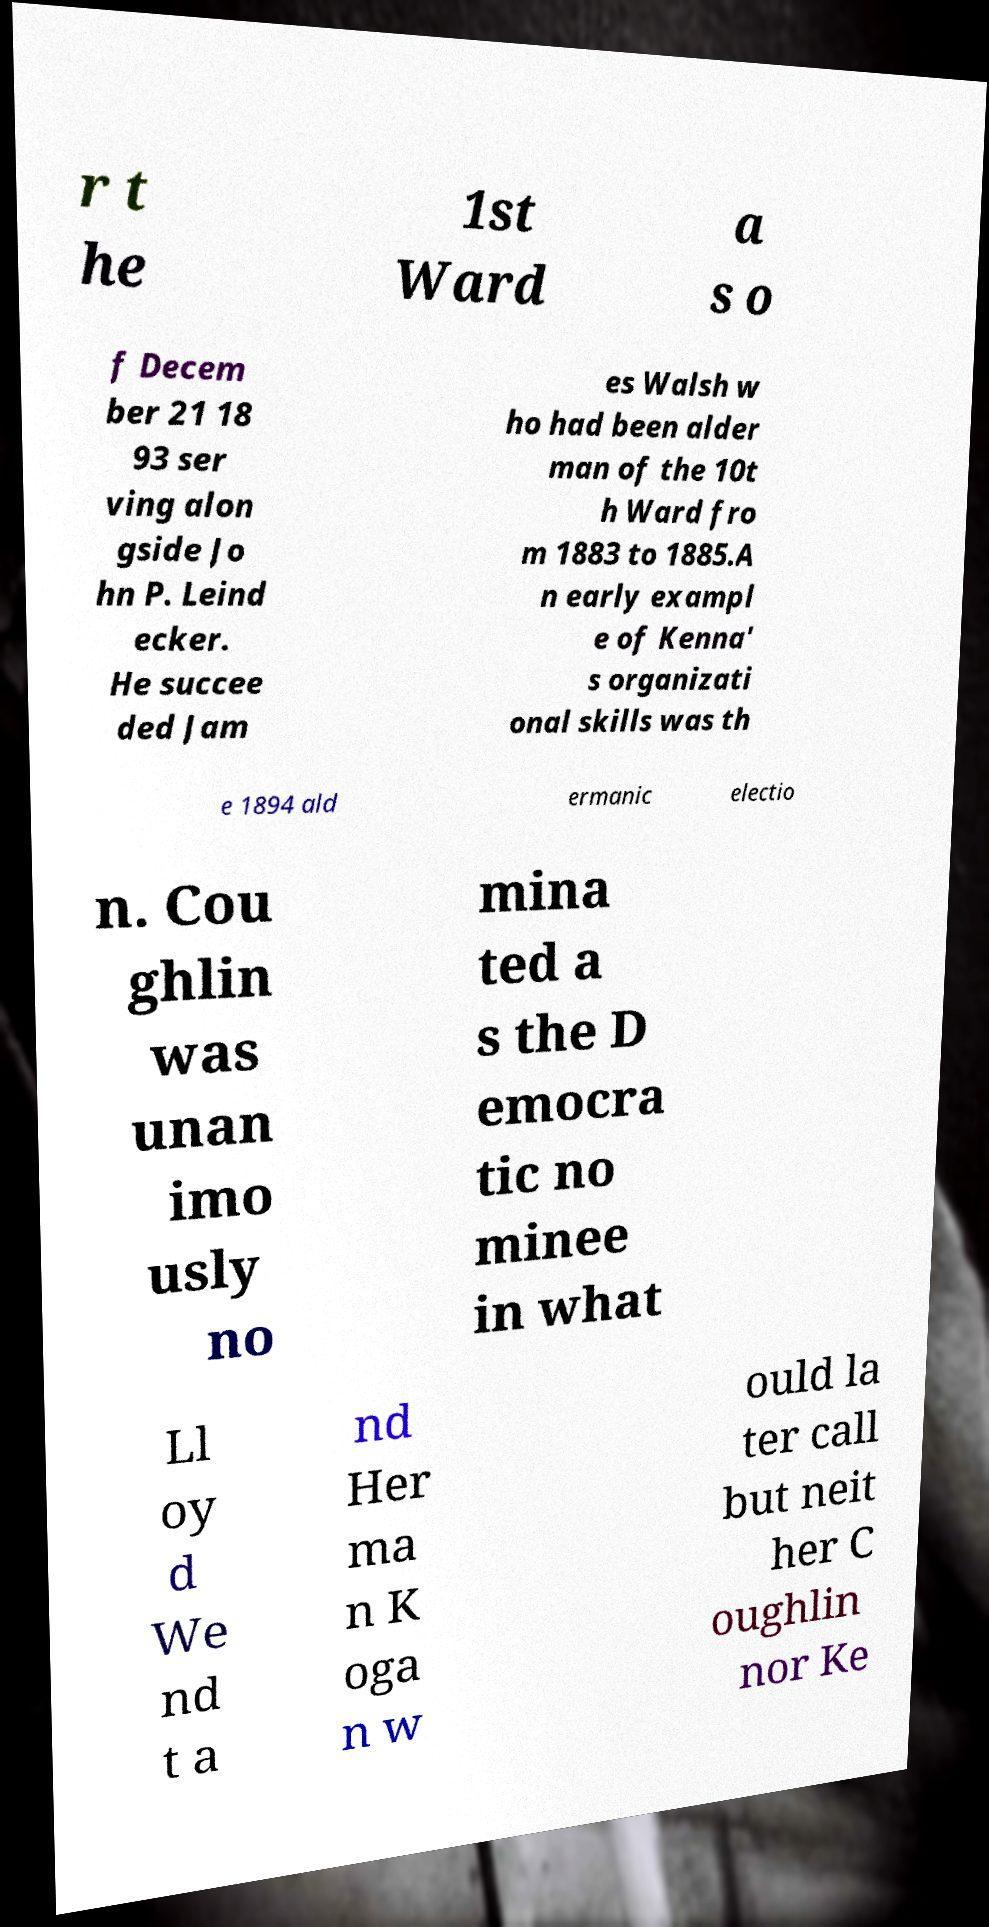Can you accurately transcribe the text from the provided image for me? r t he 1st Ward a s o f Decem ber 21 18 93 ser ving alon gside Jo hn P. Leind ecker. He succee ded Jam es Walsh w ho had been alder man of the 10t h Ward fro m 1883 to 1885.A n early exampl e of Kenna' s organizati onal skills was th e 1894 ald ermanic electio n. Cou ghlin was unan imo usly no mina ted a s the D emocra tic no minee in what Ll oy d We nd t a nd Her ma n K oga n w ould la ter call but neit her C oughlin nor Ke 